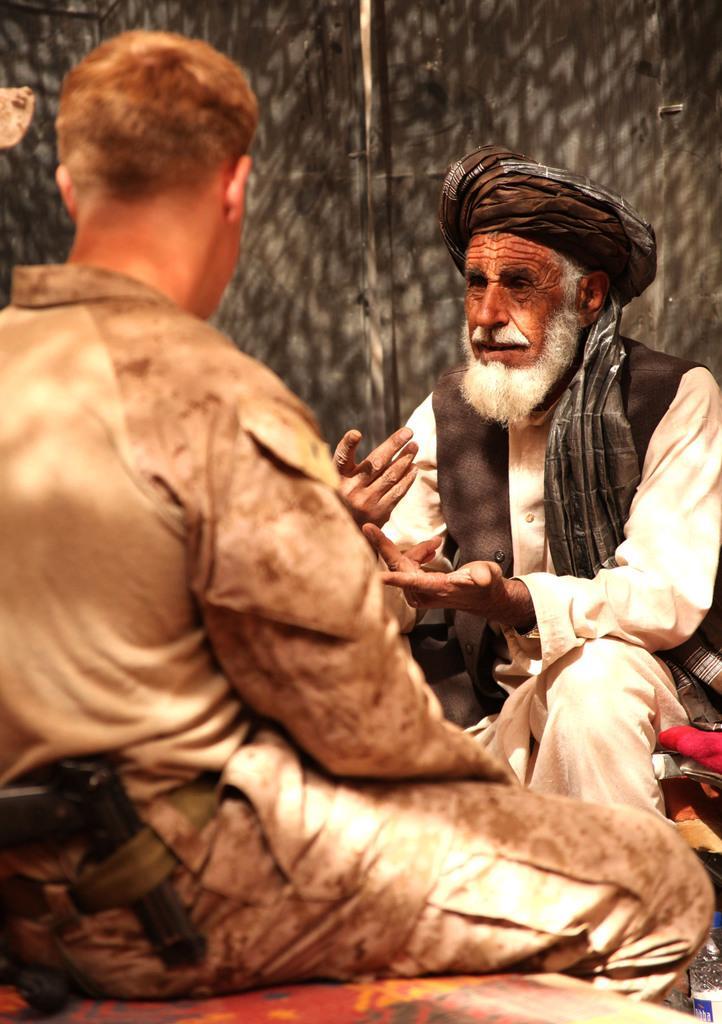Can you describe this image briefly? On the left side, there is a person having a gun, sitting on a surface. In front of him, there is another person, sitting and speaking. And the background is blurred. 